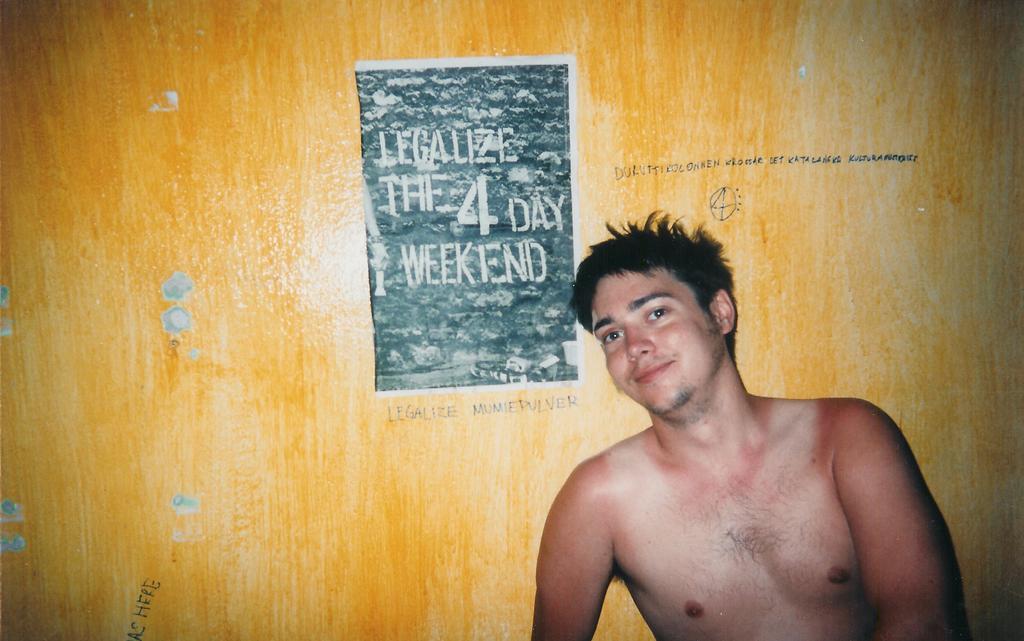In one or two sentences, can you explain what this image depicts? In this image there is a person, in the background there is a wall, on that wall there is some text. 